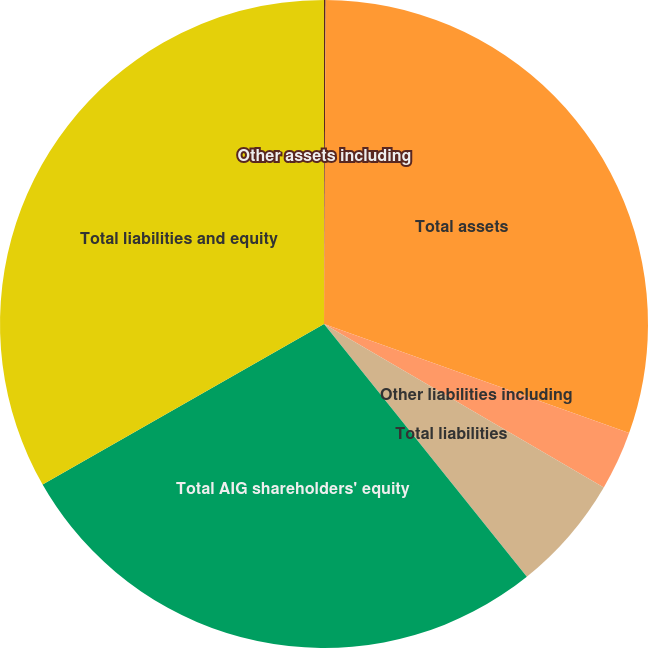Convert chart to OTSL. <chart><loc_0><loc_0><loc_500><loc_500><pie_chart><fcel>Other assets including<fcel>Total assets<fcel>Other liabilities including<fcel>Total liabilities<fcel>Total AIG shareholders' equity<fcel>Total liabilities and equity<nl><fcel>0.08%<fcel>30.38%<fcel>2.95%<fcel>5.82%<fcel>27.51%<fcel>33.25%<nl></chart> 